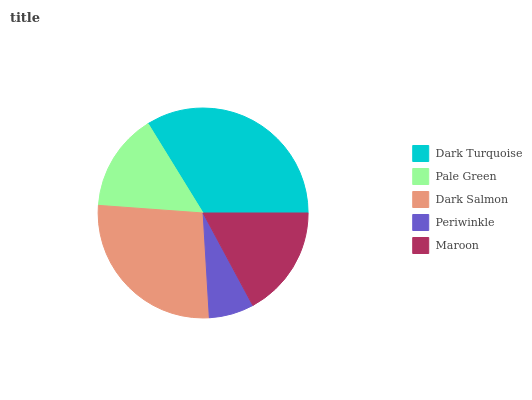Is Periwinkle the minimum?
Answer yes or no. Yes. Is Dark Turquoise the maximum?
Answer yes or no. Yes. Is Pale Green the minimum?
Answer yes or no. No. Is Pale Green the maximum?
Answer yes or no. No. Is Dark Turquoise greater than Pale Green?
Answer yes or no. Yes. Is Pale Green less than Dark Turquoise?
Answer yes or no. Yes. Is Pale Green greater than Dark Turquoise?
Answer yes or no. No. Is Dark Turquoise less than Pale Green?
Answer yes or no. No. Is Maroon the high median?
Answer yes or no. Yes. Is Maroon the low median?
Answer yes or no. Yes. Is Dark Turquoise the high median?
Answer yes or no. No. Is Periwinkle the low median?
Answer yes or no. No. 